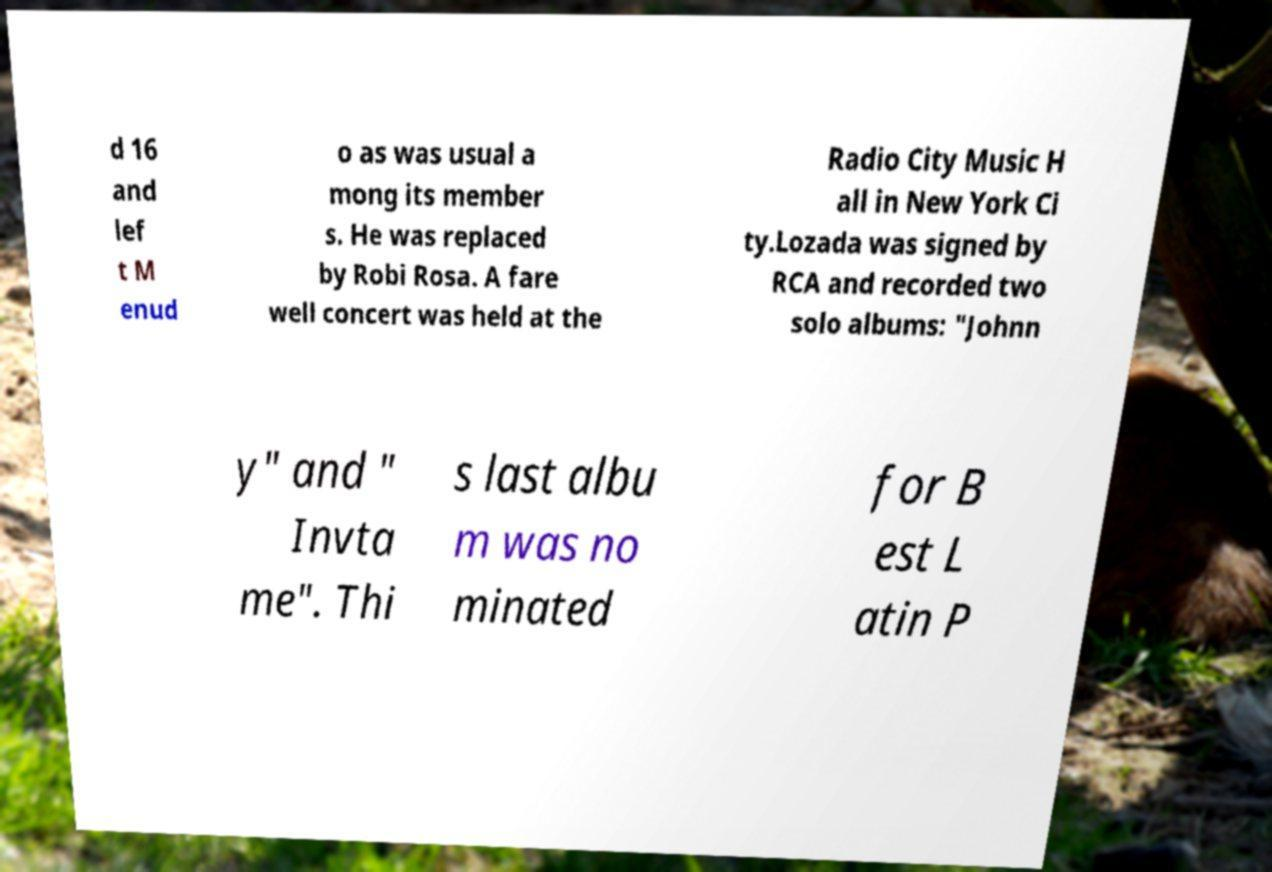Could you assist in decoding the text presented in this image and type it out clearly? d 16 and lef t M enud o as was usual a mong its member s. He was replaced by Robi Rosa. A fare well concert was held at the Radio City Music H all in New York Ci ty.Lozada was signed by RCA and recorded two solo albums: "Johnn y" and " Invta me". Thi s last albu m was no minated for B est L atin P 